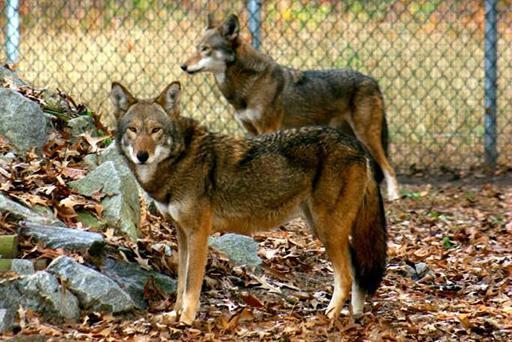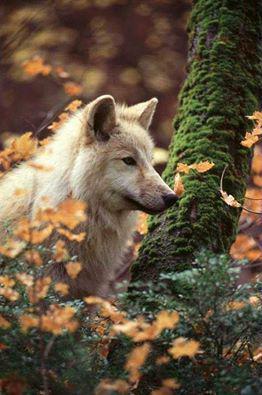The first image is the image on the left, the second image is the image on the right. Examine the images to the left and right. Is the description "Each image shows a single foreground wolf posed in a scene of colorful foliage." accurate? Answer yes or no. No. 